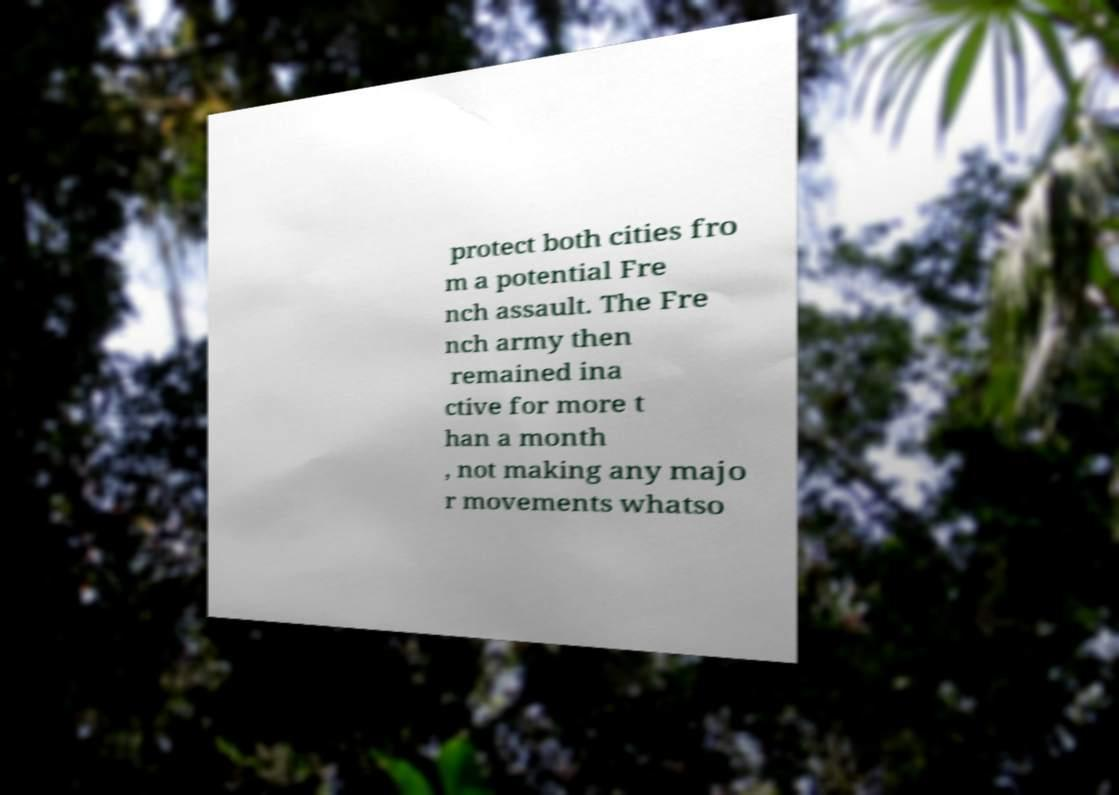I need the written content from this picture converted into text. Can you do that? protect both cities fro m a potential Fre nch assault. The Fre nch army then remained ina ctive for more t han a month , not making any majo r movements whatso 